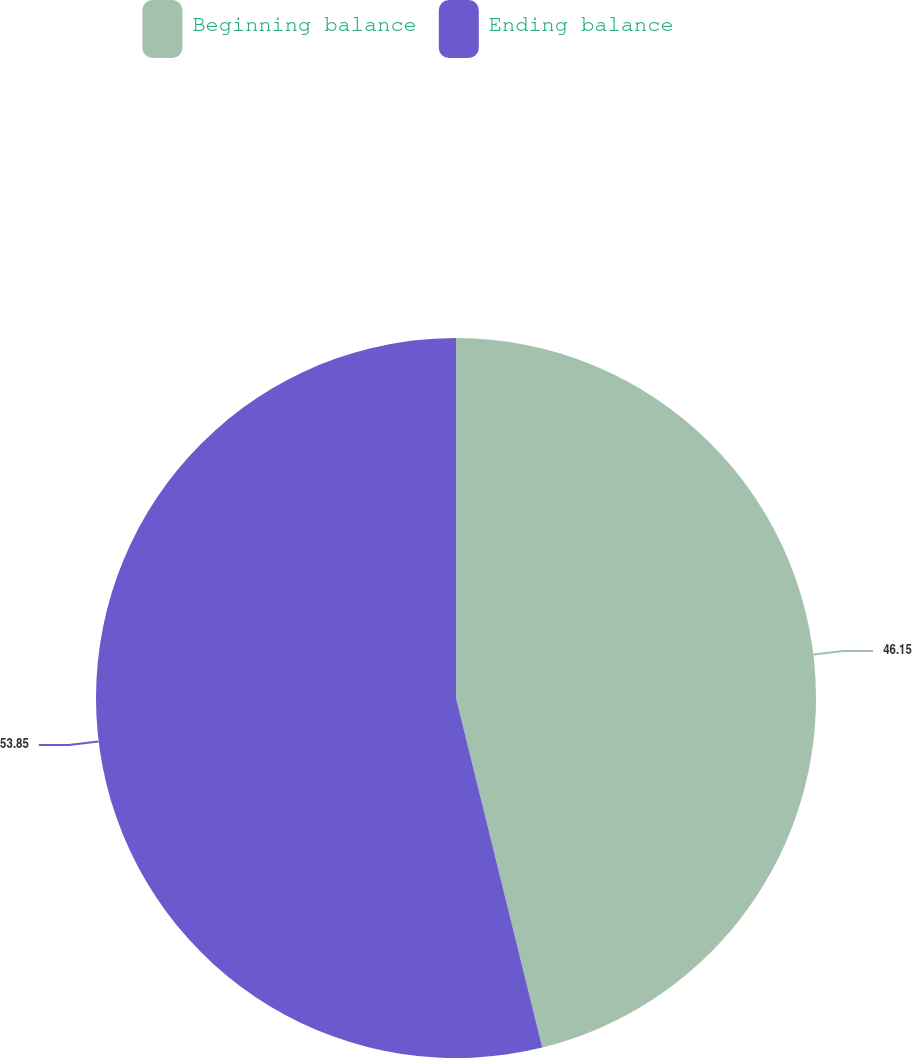Convert chart. <chart><loc_0><loc_0><loc_500><loc_500><pie_chart><fcel>Beginning balance<fcel>Ending balance<nl><fcel>46.15%<fcel>53.85%<nl></chart> 